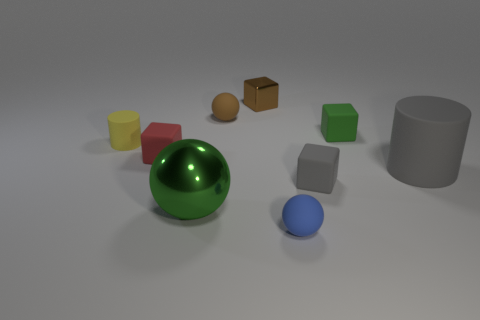Subtract all small green rubber blocks. How many blocks are left? 3 Subtract all red blocks. How many blocks are left? 3 Subtract 2 cylinders. How many cylinders are left? 0 Subtract all gray cubes. Subtract all yellow balls. How many cubes are left? 3 Subtract all blue spheres. How many gray cylinders are left? 1 Subtract all tiny cylinders. Subtract all cyan metal things. How many objects are left? 8 Add 5 small red rubber objects. How many small red rubber objects are left? 6 Add 4 large blue metal cylinders. How many large blue metal cylinders exist? 4 Subtract 0 green cylinders. How many objects are left? 9 Subtract all cylinders. How many objects are left? 7 